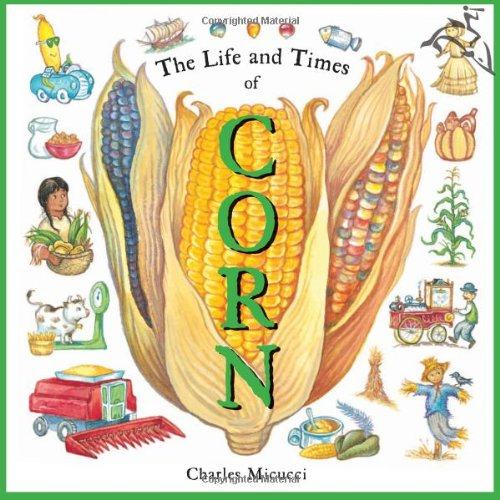What is the genre of this book? 'The Life and Times of Corn' is categorized under Children's Books. It's crafted to captivate young minds with fascinating facts and illustrations about corn. 